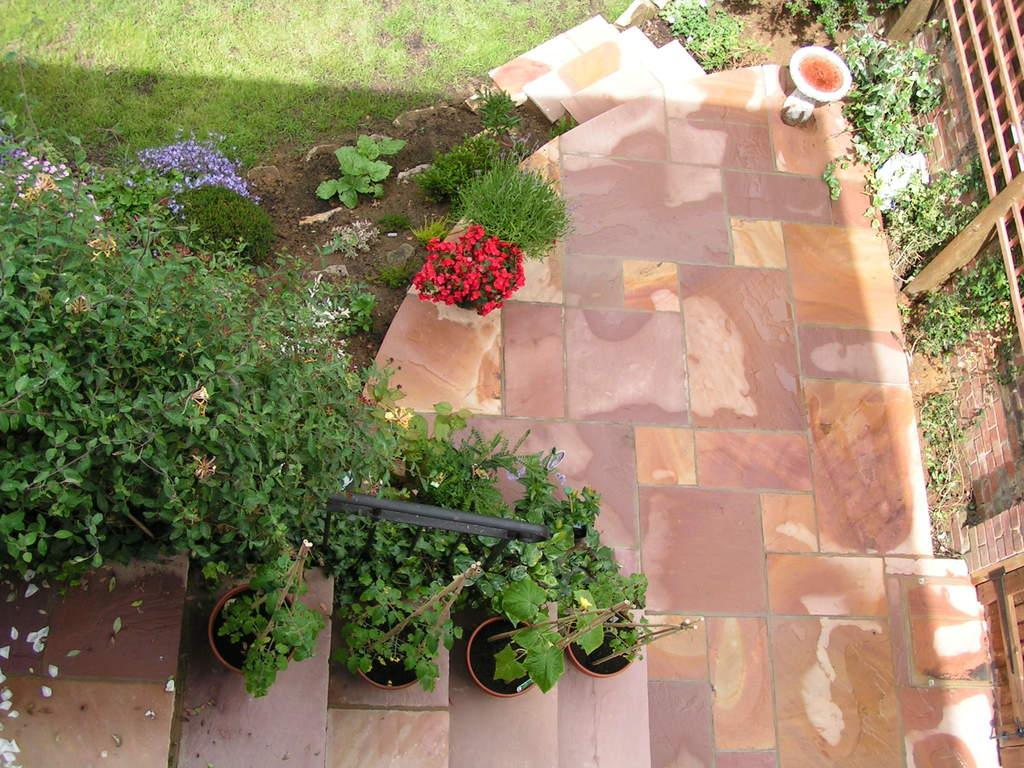What type of living organisms can be seen in the image? Plants can be seen in the image. What architectural feature is present in the image? There is a staircase in the image. What type of natural environment is visible in the background of the image? Grass is visible in the background of the image. What surface is visible in the image? There is a floor in the image. What is located on the right side of the image? There is a wall on the right side of the image. How many visitors can be seen exchanging icicles in the image? There are no visitors or icicles present in the image. What type of exchange is taking place between the plants in the image? There is no exchange taking place between the plants in the image; they are stationary. 